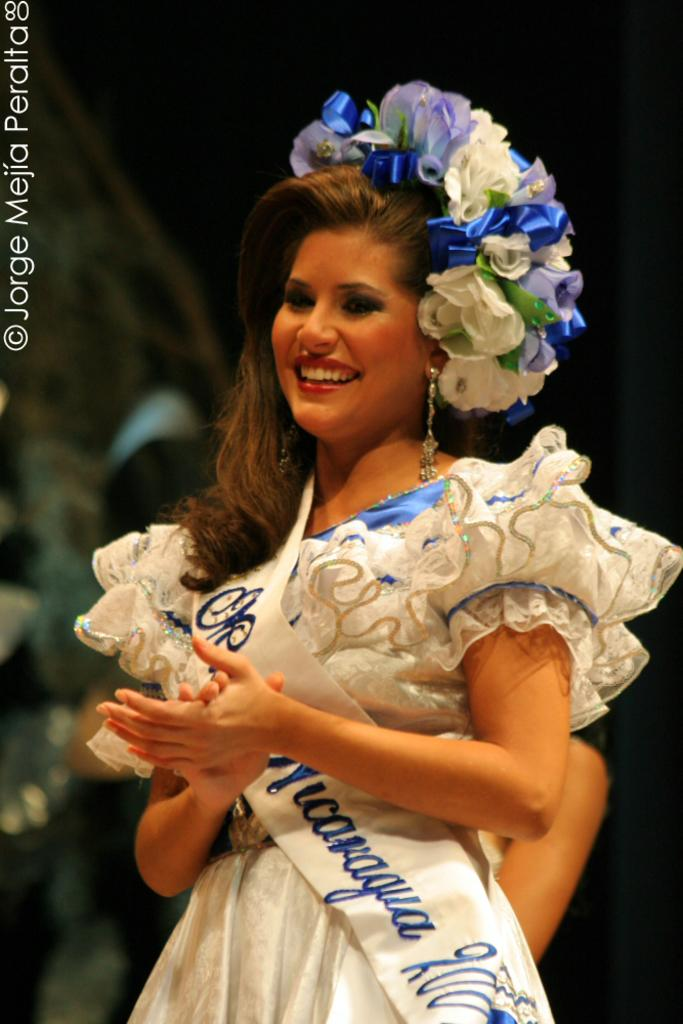<image>
Describe the image concisely. A woman in blue and white dress has the logo for Jorge mejia peralta on the top left side. 